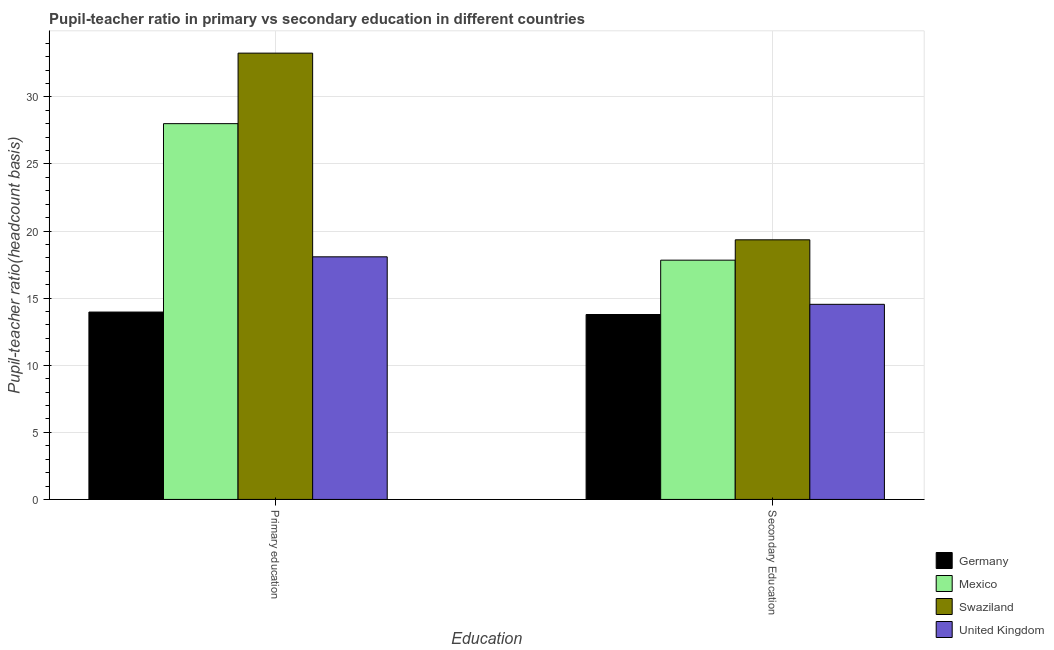Are the number of bars on each tick of the X-axis equal?
Provide a succinct answer. Yes. How many bars are there on the 1st tick from the left?
Give a very brief answer. 4. What is the label of the 2nd group of bars from the left?
Your response must be concise. Secondary Education. What is the pupil-teacher ratio in primary education in Germany?
Your response must be concise. 13.96. Across all countries, what is the maximum pupil teacher ratio on secondary education?
Provide a succinct answer. 19.35. Across all countries, what is the minimum pupil teacher ratio on secondary education?
Give a very brief answer. 13.78. In which country was the pupil-teacher ratio in primary education maximum?
Keep it short and to the point. Swaziland. In which country was the pupil-teacher ratio in primary education minimum?
Give a very brief answer. Germany. What is the total pupil teacher ratio on secondary education in the graph?
Make the answer very short. 65.5. What is the difference between the pupil-teacher ratio in primary education in Swaziland and that in Mexico?
Provide a succinct answer. 5.25. What is the difference between the pupil-teacher ratio in primary education in Germany and the pupil teacher ratio on secondary education in Swaziland?
Keep it short and to the point. -5.38. What is the average pupil teacher ratio on secondary education per country?
Ensure brevity in your answer.  16.37. What is the difference between the pupil-teacher ratio in primary education and pupil teacher ratio on secondary education in Germany?
Keep it short and to the point. 0.18. In how many countries, is the pupil teacher ratio on secondary education greater than 14 ?
Provide a short and direct response. 3. What is the ratio of the pupil-teacher ratio in primary education in Mexico to that in Germany?
Give a very brief answer. 2.01. Is the pupil teacher ratio on secondary education in Germany less than that in Mexico?
Keep it short and to the point. Yes. What does the 1st bar from the left in Primary education represents?
Ensure brevity in your answer.  Germany. What does the 2nd bar from the right in Secondary Education represents?
Provide a succinct answer. Swaziland. How many bars are there?
Keep it short and to the point. 8. Are all the bars in the graph horizontal?
Offer a very short reply. No. How many countries are there in the graph?
Give a very brief answer. 4. What is the difference between two consecutive major ticks on the Y-axis?
Provide a succinct answer. 5. Are the values on the major ticks of Y-axis written in scientific E-notation?
Make the answer very short. No. How many legend labels are there?
Provide a succinct answer. 4. What is the title of the graph?
Make the answer very short. Pupil-teacher ratio in primary vs secondary education in different countries. What is the label or title of the X-axis?
Your answer should be compact. Education. What is the label or title of the Y-axis?
Provide a succinct answer. Pupil-teacher ratio(headcount basis). What is the Pupil-teacher ratio(headcount basis) of Germany in Primary education?
Offer a terse response. 13.96. What is the Pupil-teacher ratio(headcount basis) of Mexico in Primary education?
Your answer should be very brief. 28. What is the Pupil-teacher ratio(headcount basis) in Swaziland in Primary education?
Your answer should be compact. 33.26. What is the Pupil-teacher ratio(headcount basis) of United Kingdom in Primary education?
Your response must be concise. 18.08. What is the Pupil-teacher ratio(headcount basis) in Germany in Secondary Education?
Keep it short and to the point. 13.78. What is the Pupil-teacher ratio(headcount basis) in Mexico in Secondary Education?
Keep it short and to the point. 17.83. What is the Pupil-teacher ratio(headcount basis) of Swaziland in Secondary Education?
Make the answer very short. 19.35. What is the Pupil-teacher ratio(headcount basis) in United Kingdom in Secondary Education?
Give a very brief answer. 14.54. Across all Education, what is the maximum Pupil-teacher ratio(headcount basis) in Germany?
Ensure brevity in your answer.  13.96. Across all Education, what is the maximum Pupil-teacher ratio(headcount basis) in Mexico?
Make the answer very short. 28. Across all Education, what is the maximum Pupil-teacher ratio(headcount basis) of Swaziland?
Provide a succinct answer. 33.26. Across all Education, what is the maximum Pupil-teacher ratio(headcount basis) of United Kingdom?
Offer a very short reply. 18.08. Across all Education, what is the minimum Pupil-teacher ratio(headcount basis) in Germany?
Make the answer very short. 13.78. Across all Education, what is the minimum Pupil-teacher ratio(headcount basis) in Mexico?
Your answer should be very brief. 17.83. Across all Education, what is the minimum Pupil-teacher ratio(headcount basis) in Swaziland?
Your response must be concise. 19.35. Across all Education, what is the minimum Pupil-teacher ratio(headcount basis) of United Kingdom?
Make the answer very short. 14.54. What is the total Pupil-teacher ratio(headcount basis) in Germany in the graph?
Your answer should be compact. 27.75. What is the total Pupil-teacher ratio(headcount basis) in Mexico in the graph?
Give a very brief answer. 45.83. What is the total Pupil-teacher ratio(headcount basis) in Swaziland in the graph?
Your response must be concise. 52.61. What is the total Pupil-teacher ratio(headcount basis) of United Kingdom in the graph?
Ensure brevity in your answer.  32.62. What is the difference between the Pupil-teacher ratio(headcount basis) in Germany in Primary education and that in Secondary Education?
Offer a terse response. 0.18. What is the difference between the Pupil-teacher ratio(headcount basis) in Mexico in Primary education and that in Secondary Education?
Your answer should be compact. 10.17. What is the difference between the Pupil-teacher ratio(headcount basis) of Swaziland in Primary education and that in Secondary Education?
Provide a succinct answer. 13.91. What is the difference between the Pupil-teacher ratio(headcount basis) of United Kingdom in Primary education and that in Secondary Education?
Offer a terse response. 3.54. What is the difference between the Pupil-teacher ratio(headcount basis) in Germany in Primary education and the Pupil-teacher ratio(headcount basis) in Mexico in Secondary Education?
Your response must be concise. -3.87. What is the difference between the Pupil-teacher ratio(headcount basis) of Germany in Primary education and the Pupil-teacher ratio(headcount basis) of Swaziland in Secondary Education?
Provide a short and direct response. -5.38. What is the difference between the Pupil-teacher ratio(headcount basis) of Germany in Primary education and the Pupil-teacher ratio(headcount basis) of United Kingdom in Secondary Education?
Ensure brevity in your answer.  -0.58. What is the difference between the Pupil-teacher ratio(headcount basis) in Mexico in Primary education and the Pupil-teacher ratio(headcount basis) in Swaziland in Secondary Education?
Offer a terse response. 8.66. What is the difference between the Pupil-teacher ratio(headcount basis) of Mexico in Primary education and the Pupil-teacher ratio(headcount basis) of United Kingdom in Secondary Education?
Your answer should be compact. 13.46. What is the difference between the Pupil-teacher ratio(headcount basis) of Swaziland in Primary education and the Pupil-teacher ratio(headcount basis) of United Kingdom in Secondary Education?
Make the answer very short. 18.72. What is the average Pupil-teacher ratio(headcount basis) of Germany per Education?
Provide a succinct answer. 13.87. What is the average Pupil-teacher ratio(headcount basis) of Mexico per Education?
Provide a short and direct response. 22.92. What is the average Pupil-teacher ratio(headcount basis) in Swaziland per Education?
Ensure brevity in your answer.  26.3. What is the average Pupil-teacher ratio(headcount basis) in United Kingdom per Education?
Provide a short and direct response. 16.31. What is the difference between the Pupil-teacher ratio(headcount basis) in Germany and Pupil-teacher ratio(headcount basis) in Mexico in Primary education?
Provide a short and direct response. -14.04. What is the difference between the Pupil-teacher ratio(headcount basis) of Germany and Pupil-teacher ratio(headcount basis) of Swaziland in Primary education?
Keep it short and to the point. -19.3. What is the difference between the Pupil-teacher ratio(headcount basis) in Germany and Pupil-teacher ratio(headcount basis) in United Kingdom in Primary education?
Offer a terse response. -4.12. What is the difference between the Pupil-teacher ratio(headcount basis) in Mexico and Pupil-teacher ratio(headcount basis) in Swaziland in Primary education?
Your answer should be compact. -5.25. What is the difference between the Pupil-teacher ratio(headcount basis) in Mexico and Pupil-teacher ratio(headcount basis) in United Kingdom in Primary education?
Your answer should be compact. 9.92. What is the difference between the Pupil-teacher ratio(headcount basis) in Swaziland and Pupil-teacher ratio(headcount basis) in United Kingdom in Primary education?
Provide a succinct answer. 15.18. What is the difference between the Pupil-teacher ratio(headcount basis) of Germany and Pupil-teacher ratio(headcount basis) of Mexico in Secondary Education?
Give a very brief answer. -4.05. What is the difference between the Pupil-teacher ratio(headcount basis) in Germany and Pupil-teacher ratio(headcount basis) in Swaziland in Secondary Education?
Offer a terse response. -5.57. What is the difference between the Pupil-teacher ratio(headcount basis) of Germany and Pupil-teacher ratio(headcount basis) of United Kingdom in Secondary Education?
Your response must be concise. -0.76. What is the difference between the Pupil-teacher ratio(headcount basis) in Mexico and Pupil-teacher ratio(headcount basis) in Swaziland in Secondary Education?
Your answer should be very brief. -1.52. What is the difference between the Pupil-teacher ratio(headcount basis) of Mexico and Pupil-teacher ratio(headcount basis) of United Kingdom in Secondary Education?
Your response must be concise. 3.29. What is the difference between the Pupil-teacher ratio(headcount basis) of Swaziland and Pupil-teacher ratio(headcount basis) of United Kingdom in Secondary Education?
Your answer should be compact. 4.81. What is the ratio of the Pupil-teacher ratio(headcount basis) in Germany in Primary education to that in Secondary Education?
Ensure brevity in your answer.  1.01. What is the ratio of the Pupil-teacher ratio(headcount basis) in Mexico in Primary education to that in Secondary Education?
Your response must be concise. 1.57. What is the ratio of the Pupil-teacher ratio(headcount basis) in Swaziland in Primary education to that in Secondary Education?
Keep it short and to the point. 1.72. What is the ratio of the Pupil-teacher ratio(headcount basis) in United Kingdom in Primary education to that in Secondary Education?
Your answer should be very brief. 1.24. What is the difference between the highest and the second highest Pupil-teacher ratio(headcount basis) in Germany?
Ensure brevity in your answer.  0.18. What is the difference between the highest and the second highest Pupil-teacher ratio(headcount basis) in Mexico?
Your answer should be very brief. 10.17. What is the difference between the highest and the second highest Pupil-teacher ratio(headcount basis) in Swaziland?
Your answer should be very brief. 13.91. What is the difference between the highest and the second highest Pupil-teacher ratio(headcount basis) of United Kingdom?
Keep it short and to the point. 3.54. What is the difference between the highest and the lowest Pupil-teacher ratio(headcount basis) of Germany?
Your answer should be compact. 0.18. What is the difference between the highest and the lowest Pupil-teacher ratio(headcount basis) in Mexico?
Offer a terse response. 10.17. What is the difference between the highest and the lowest Pupil-teacher ratio(headcount basis) of Swaziland?
Offer a terse response. 13.91. What is the difference between the highest and the lowest Pupil-teacher ratio(headcount basis) of United Kingdom?
Your answer should be compact. 3.54. 